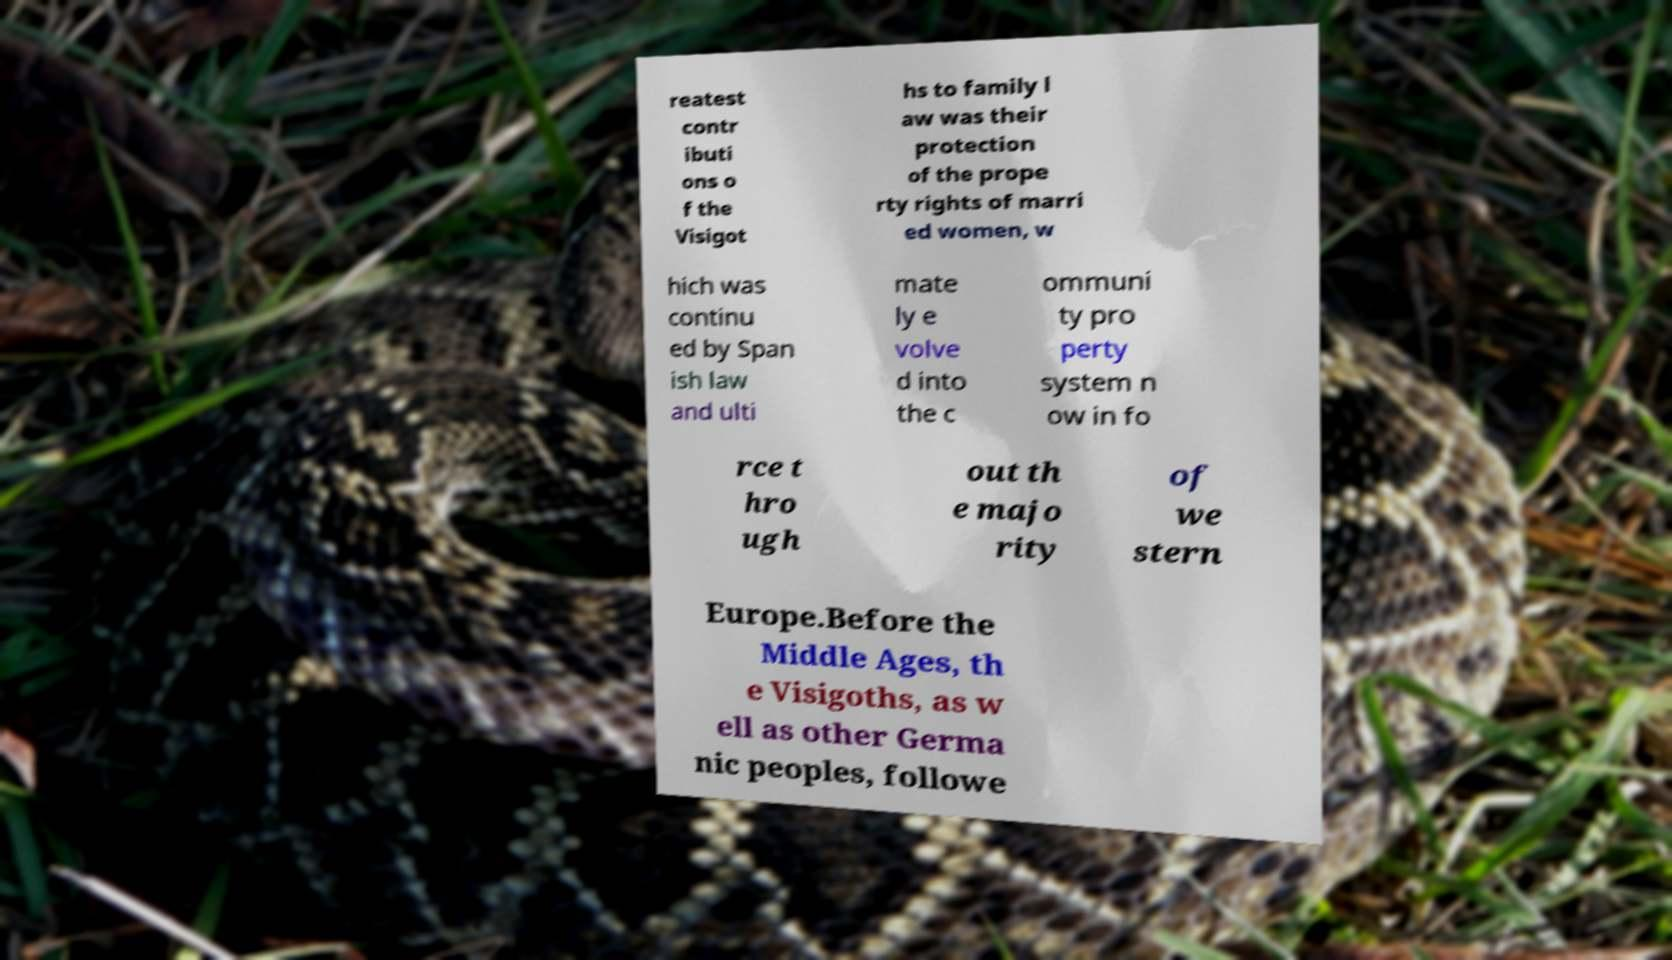I need the written content from this picture converted into text. Can you do that? reatest contr ibuti ons o f the Visigot hs to family l aw was their protection of the prope rty rights of marri ed women, w hich was continu ed by Span ish law and ulti mate ly e volve d into the c ommuni ty pro perty system n ow in fo rce t hro ugh out th e majo rity of we stern Europe.Before the Middle Ages, th e Visigoths, as w ell as other Germa nic peoples, followe 